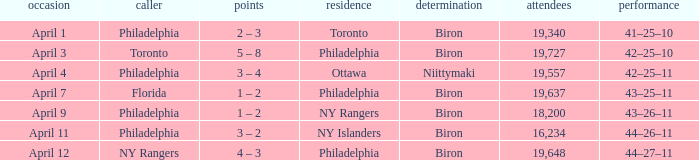What was the flyers' record when the visitors were florida? 43–25–11. 